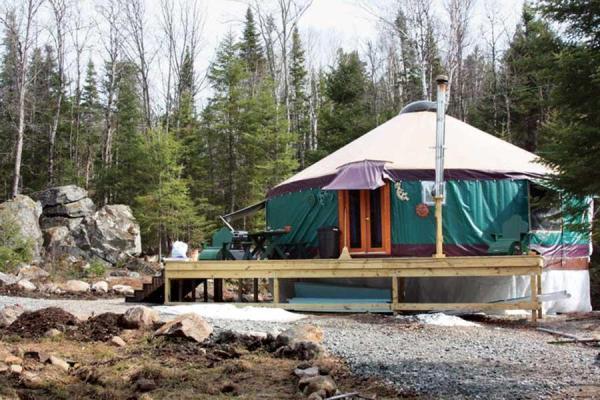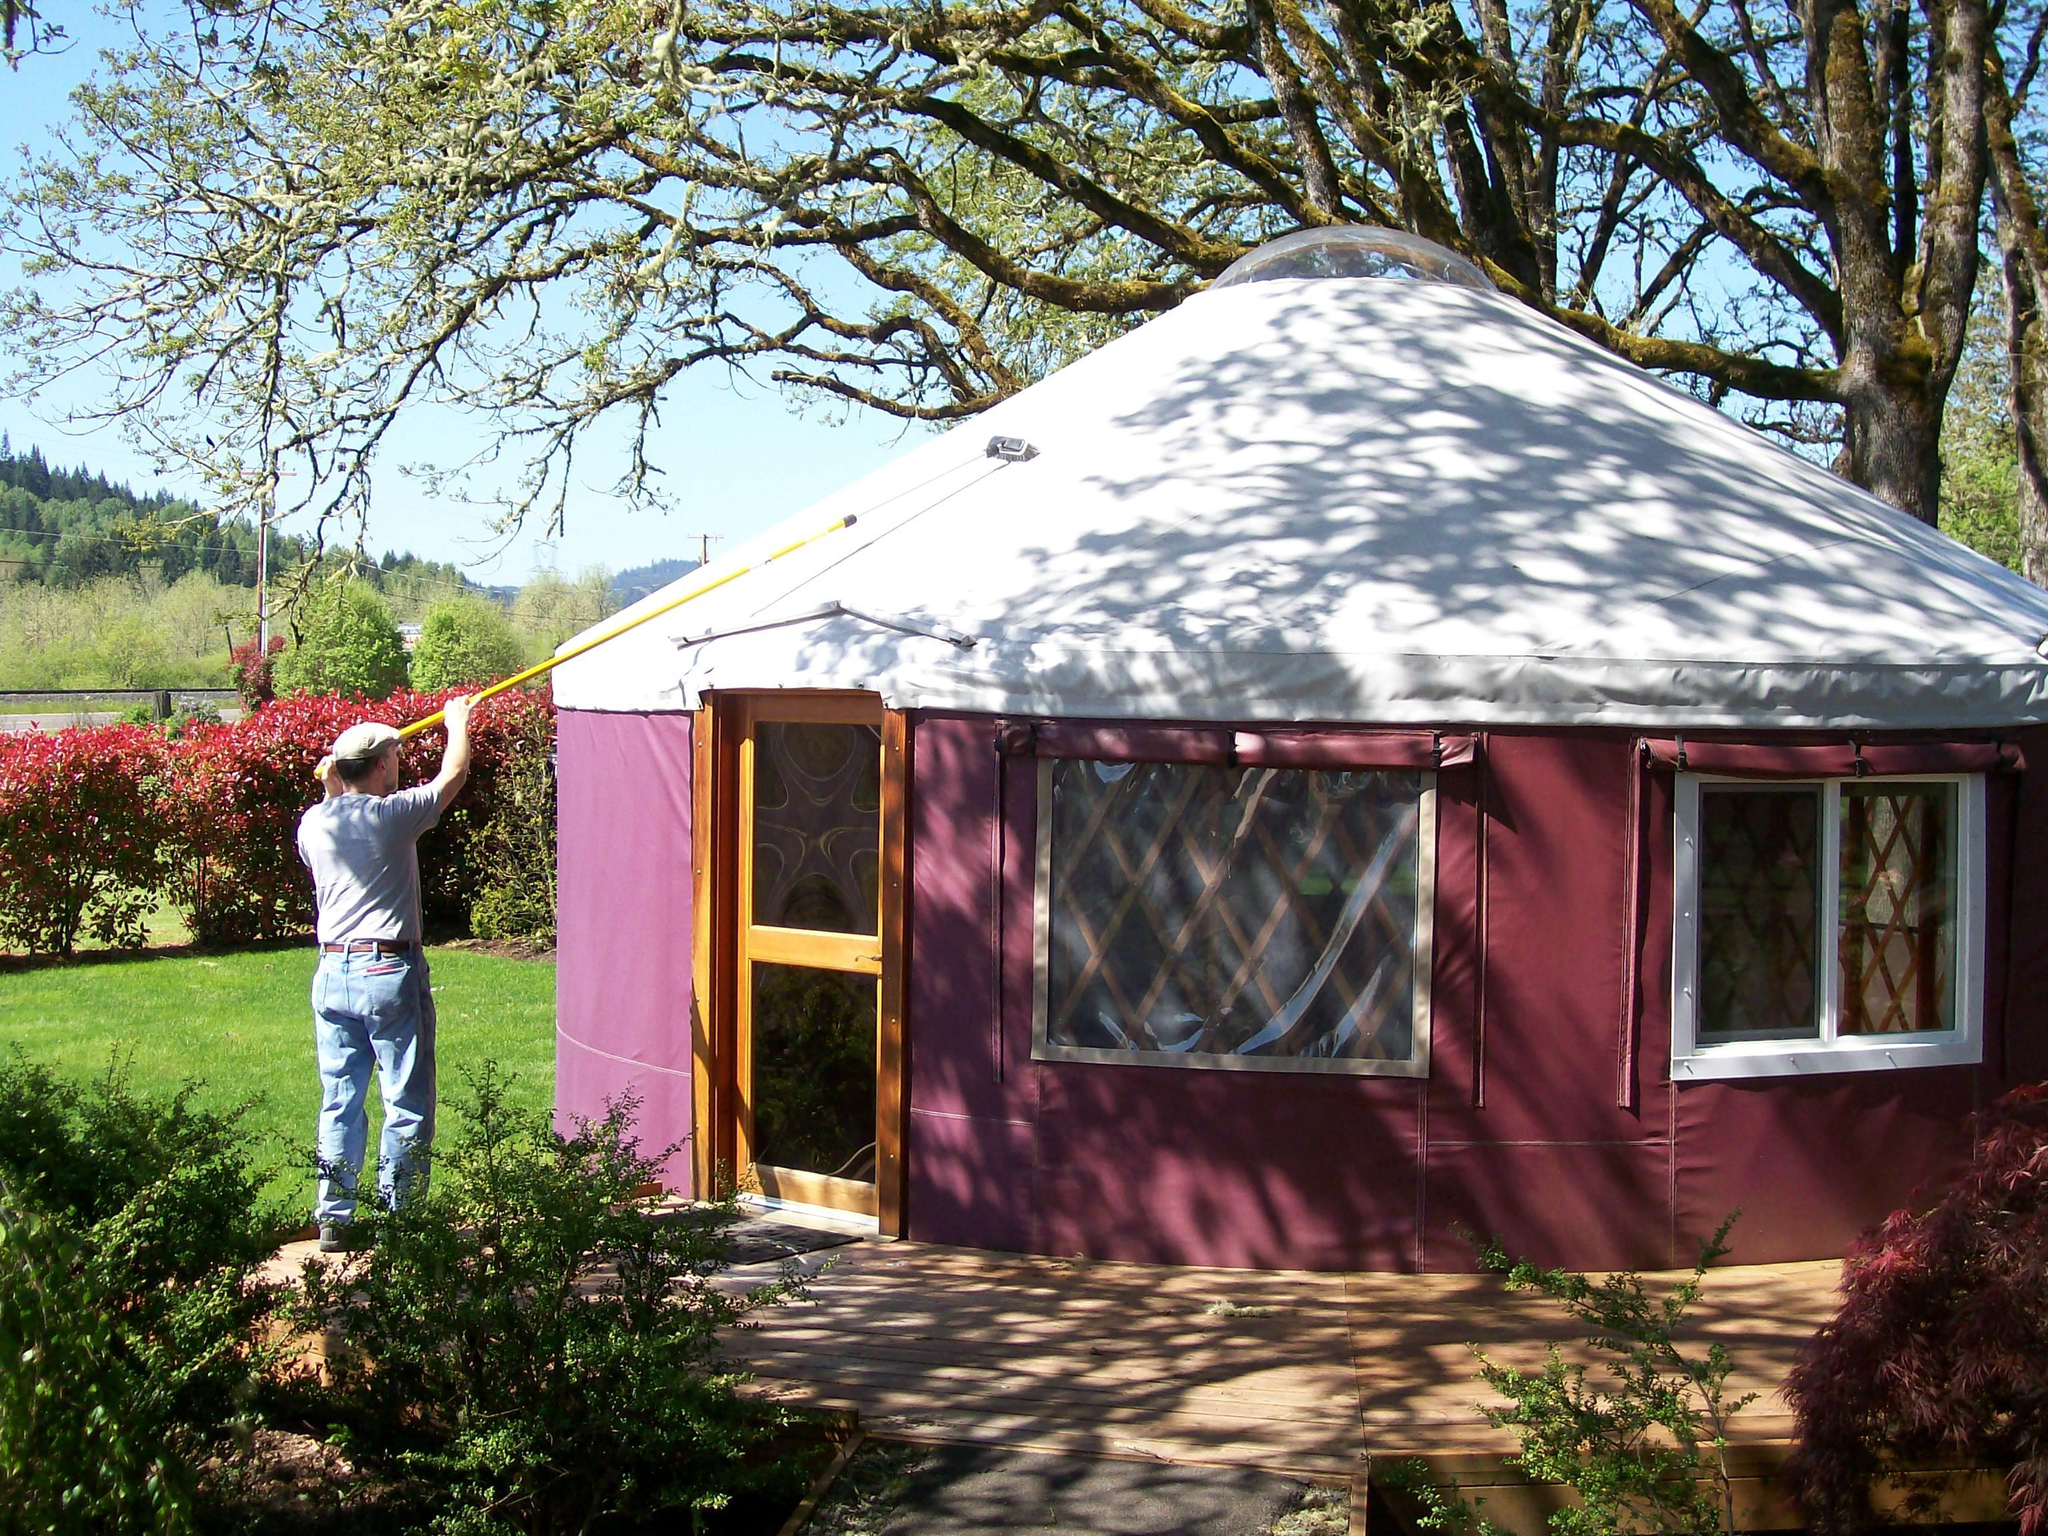The first image is the image on the left, the second image is the image on the right. For the images shown, is this caption "In one image, a round wooden house is under construction with an incomplete roof." true? Answer yes or no. No. 